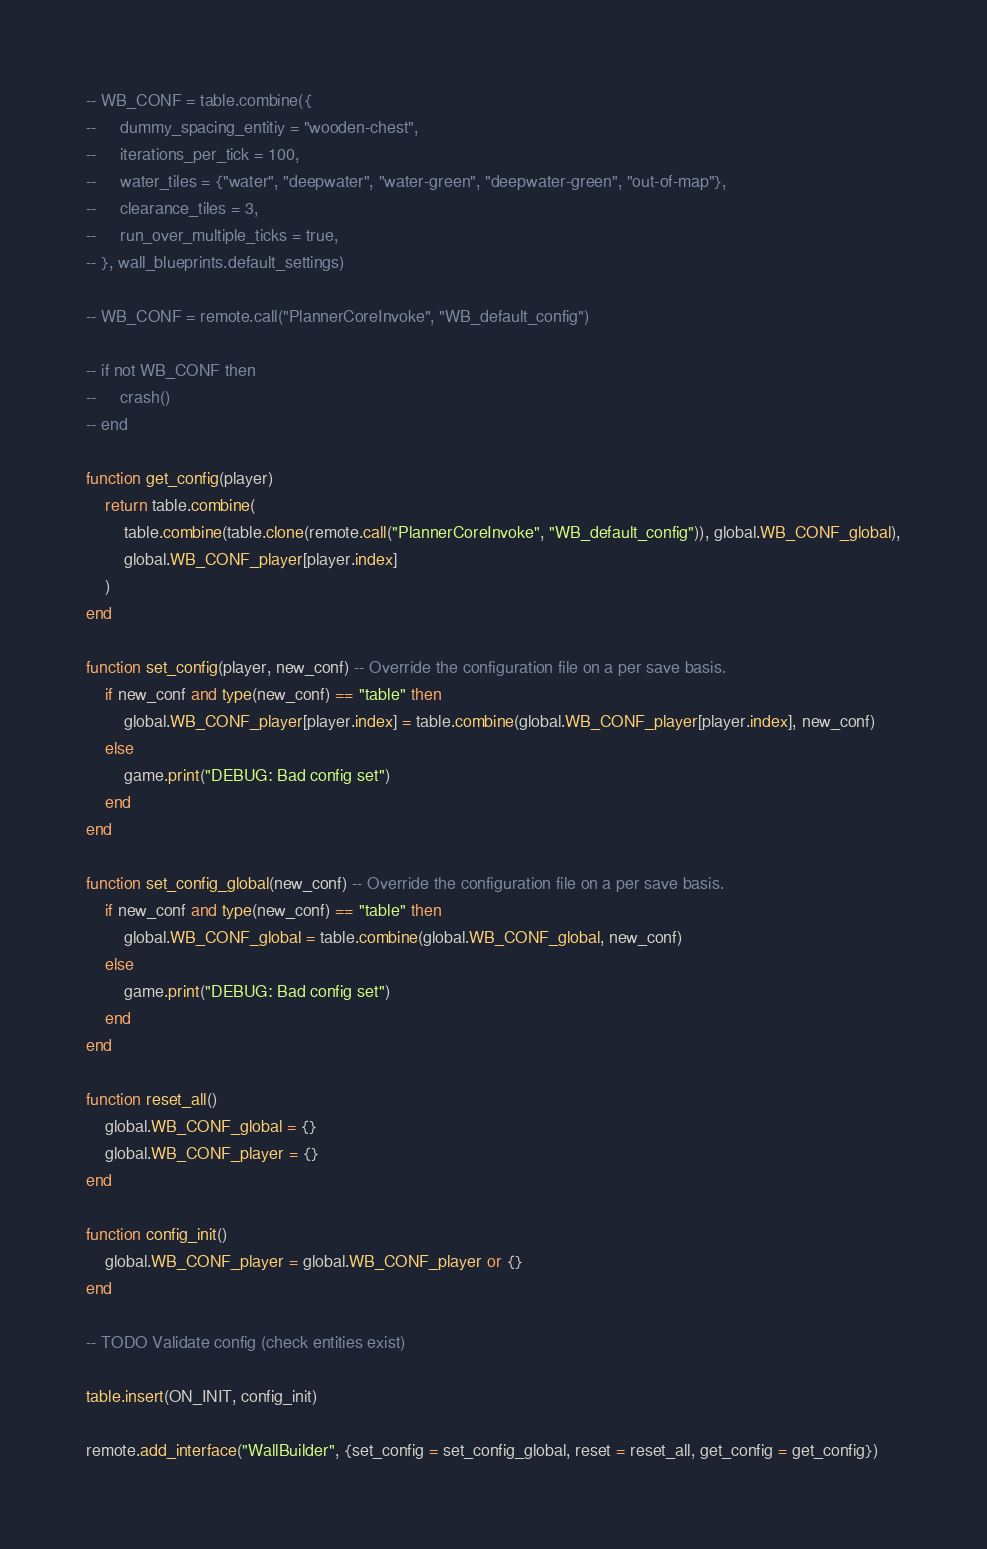<code> <loc_0><loc_0><loc_500><loc_500><_Lua_>-- WB_CONF = table.combine({
--     dummy_spacing_entitiy = "wooden-chest",
--     iterations_per_tick = 100,
--     water_tiles = {"water", "deepwater", "water-green", "deepwater-green", "out-of-map"},
--     clearance_tiles = 3,
--     run_over_multiple_ticks = true,
-- }, wall_blueprints.default_settings)

-- WB_CONF = remote.call("PlannerCoreInvoke", "WB_default_config")

-- if not WB_CONF then
--     crash()
-- end

function get_config(player)
    return table.combine(
        table.combine(table.clone(remote.call("PlannerCoreInvoke", "WB_default_config")), global.WB_CONF_global),
        global.WB_CONF_player[player.index]
    )
end

function set_config(player, new_conf) -- Override the configuration file on a per save basis.
    if new_conf and type(new_conf) == "table" then
        global.WB_CONF_player[player.index] = table.combine(global.WB_CONF_player[player.index], new_conf)
    else
        game.print("DEBUG: Bad config set")
    end
end

function set_config_global(new_conf) -- Override the configuration file on a per save basis.
    if new_conf and type(new_conf) == "table" then
        global.WB_CONF_global = table.combine(global.WB_CONF_global, new_conf)
    else
        game.print("DEBUG: Bad config set")
    end
end

function reset_all()
    global.WB_CONF_global = {}
    global.WB_CONF_player = {}
end

function config_init()
    global.WB_CONF_player = global.WB_CONF_player or {}
end

-- TODO Validate config (check entities exist)

table.insert(ON_INIT, config_init)

remote.add_interface("WallBuilder", {set_config = set_config_global, reset = reset_all, get_config = get_config})
</code> 